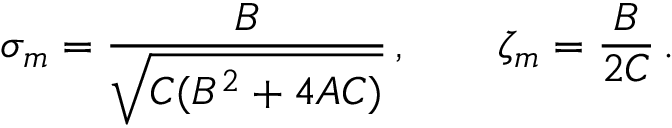Convert formula to latex. <formula><loc_0><loc_0><loc_500><loc_500>\sigma _ { m } = { \frac { B } { \sqrt { C ( B ^ { 2 } + 4 A C ) } } } \, , \quad \zeta _ { m } = { \frac { B } { 2 C } } \, .</formula> 